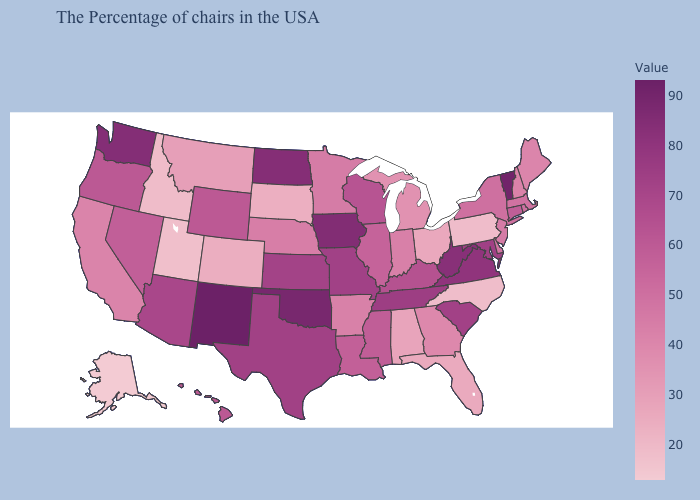Does Alaska have the lowest value in the USA?
Give a very brief answer. Yes. Among the states that border New Mexico , does Oklahoma have the highest value?
Be succinct. Yes. Among the states that border Utah , which have the lowest value?
Answer briefly. Idaho. Among the states that border Kansas , does Nebraska have the highest value?
Keep it brief. No. Does New Mexico have the highest value in the West?
Give a very brief answer. Yes. Does Montana have a lower value than Tennessee?
Be succinct. Yes. Among the states that border Illinois , which have the lowest value?
Keep it brief. Indiana. Which states hav the highest value in the Northeast?
Short answer required. Vermont. Does New Mexico have the highest value in the USA?
Give a very brief answer. Yes. 